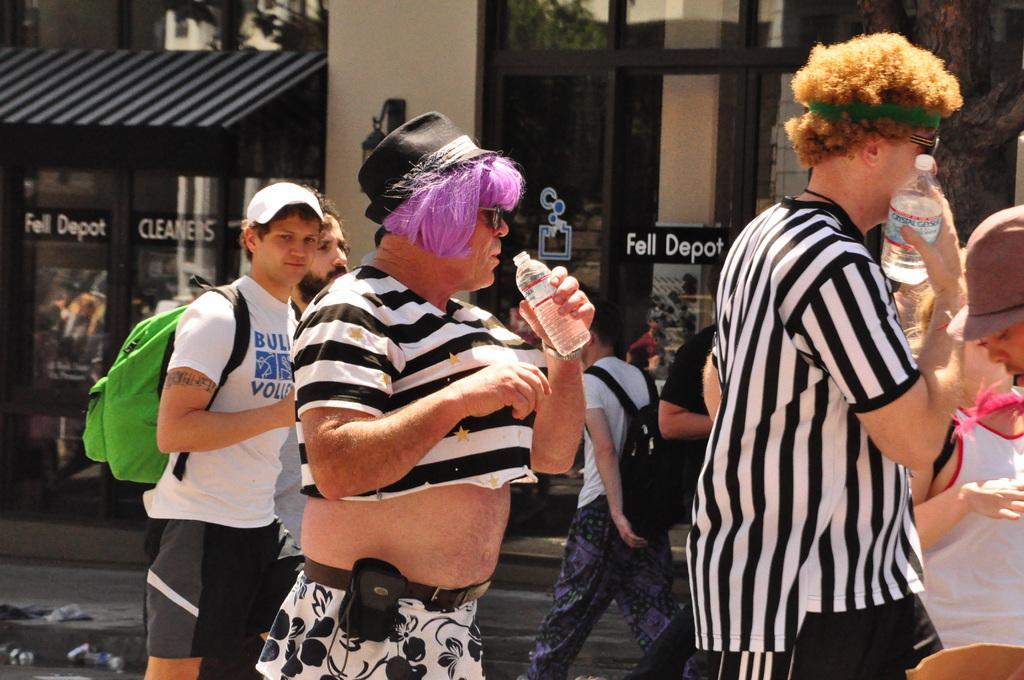How would you summarize this image in a sentence or two? In this image there are few people walking on the ground by holding the bottles. In the background there are buildings with the glass doors. On the doors there is some text. In the middle there is a man who is wearing the girl's dress. 